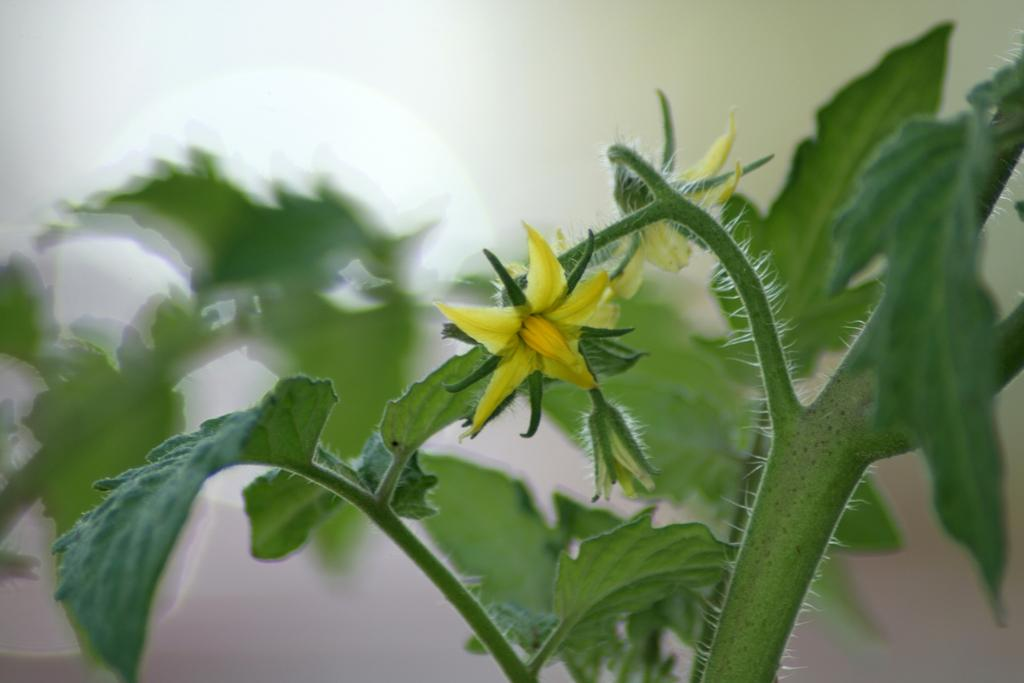What is the main subject in the foreground of the image? There is a plant in the foreground of the image. What can be seen in the background of the image? There is a wall in the background of the image. How many children are playing with the waves in the image? There are no children or waves present in the image. What type of muscle is visible on the plant in the image? Plants do not have muscles, so there is no muscle visible on the plant in the image. 